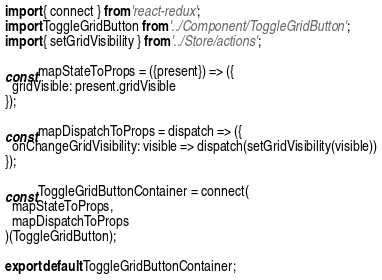Convert code to text. <code><loc_0><loc_0><loc_500><loc_500><_JavaScript_>import { connect } from 'react-redux';
import ToggleGridButton from '../Component/ToggleGridButton';
import { setGridVisibility } from '../Store/actions';

const mapStateToProps = ({present}) => ({
  gridVisible: present.gridVisible
});

const mapDispatchToProps = dispatch => ({
  onChangeGridVisibility: visible => dispatch(setGridVisibility(visible))
});

const ToggleGridButtonContainer = connect(
  mapStateToProps,
  mapDispatchToProps
)(ToggleGridButton);

export default ToggleGridButtonContainer;
</code> 